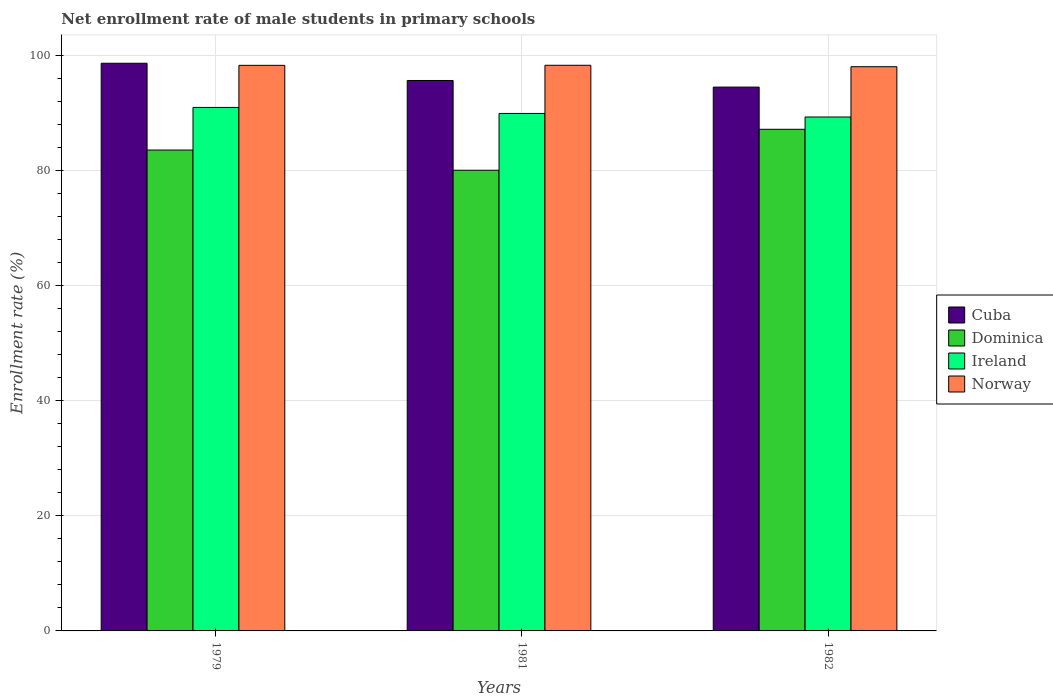How many different coloured bars are there?
Give a very brief answer. 4. Are the number of bars per tick equal to the number of legend labels?
Provide a succinct answer. Yes. Are the number of bars on each tick of the X-axis equal?
Provide a succinct answer. Yes. What is the label of the 1st group of bars from the left?
Keep it short and to the point. 1979. In how many cases, is the number of bars for a given year not equal to the number of legend labels?
Offer a terse response. 0. What is the net enrollment rate of male students in primary schools in Norway in 1981?
Your answer should be compact. 98.27. Across all years, what is the maximum net enrollment rate of male students in primary schools in Norway?
Give a very brief answer. 98.27. Across all years, what is the minimum net enrollment rate of male students in primary schools in Ireland?
Keep it short and to the point. 89.28. In which year was the net enrollment rate of male students in primary schools in Cuba maximum?
Your response must be concise. 1979. What is the total net enrollment rate of male students in primary schools in Norway in the graph?
Give a very brief answer. 294.56. What is the difference between the net enrollment rate of male students in primary schools in Ireland in 1979 and that in 1982?
Offer a very short reply. 1.66. What is the difference between the net enrollment rate of male students in primary schools in Dominica in 1981 and the net enrollment rate of male students in primary schools in Norway in 1979?
Ensure brevity in your answer.  -18.23. What is the average net enrollment rate of male students in primary schools in Cuba per year?
Give a very brief answer. 96.24. In the year 1979, what is the difference between the net enrollment rate of male students in primary schools in Norway and net enrollment rate of male students in primary schools in Dominica?
Keep it short and to the point. 14.72. In how many years, is the net enrollment rate of male students in primary schools in Ireland greater than 72 %?
Offer a very short reply. 3. What is the ratio of the net enrollment rate of male students in primary schools in Norway in 1979 to that in 1981?
Offer a terse response. 1. Is the net enrollment rate of male students in primary schools in Ireland in 1981 less than that in 1982?
Give a very brief answer. No. What is the difference between the highest and the second highest net enrollment rate of male students in primary schools in Ireland?
Keep it short and to the point. 1.05. What is the difference between the highest and the lowest net enrollment rate of male students in primary schools in Norway?
Your answer should be very brief. 0.25. Is it the case that in every year, the sum of the net enrollment rate of male students in primary schools in Ireland and net enrollment rate of male students in primary schools in Dominica is greater than the sum of net enrollment rate of male students in primary schools in Cuba and net enrollment rate of male students in primary schools in Norway?
Offer a very short reply. No. What does the 3rd bar from the left in 1979 represents?
Give a very brief answer. Ireland. What does the 4th bar from the right in 1979 represents?
Make the answer very short. Cuba. Is it the case that in every year, the sum of the net enrollment rate of male students in primary schools in Dominica and net enrollment rate of male students in primary schools in Cuba is greater than the net enrollment rate of male students in primary schools in Norway?
Make the answer very short. Yes. Does the graph contain any zero values?
Give a very brief answer. No. What is the title of the graph?
Your response must be concise. Net enrollment rate of male students in primary schools. What is the label or title of the Y-axis?
Offer a very short reply. Enrollment rate (%). What is the Enrollment rate (%) of Cuba in 1979?
Keep it short and to the point. 98.62. What is the Enrollment rate (%) in Dominica in 1979?
Provide a short and direct response. 83.55. What is the Enrollment rate (%) in Ireland in 1979?
Give a very brief answer. 90.95. What is the Enrollment rate (%) in Norway in 1979?
Provide a succinct answer. 98.26. What is the Enrollment rate (%) in Cuba in 1981?
Keep it short and to the point. 95.63. What is the Enrollment rate (%) in Dominica in 1981?
Your answer should be very brief. 80.03. What is the Enrollment rate (%) of Ireland in 1981?
Offer a terse response. 89.9. What is the Enrollment rate (%) in Norway in 1981?
Keep it short and to the point. 98.27. What is the Enrollment rate (%) of Cuba in 1982?
Your response must be concise. 94.48. What is the Enrollment rate (%) of Dominica in 1982?
Offer a terse response. 87.15. What is the Enrollment rate (%) of Ireland in 1982?
Provide a succinct answer. 89.28. What is the Enrollment rate (%) in Norway in 1982?
Keep it short and to the point. 98.02. Across all years, what is the maximum Enrollment rate (%) in Cuba?
Your answer should be compact. 98.62. Across all years, what is the maximum Enrollment rate (%) of Dominica?
Make the answer very short. 87.15. Across all years, what is the maximum Enrollment rate (%) of Ireland?
Offer a terse response. 90.95. Across all years, what is the maximum Enrollment rate (%) in Norway?
Provide a succinct answer. 98.27. Across all years, what is the minimum Enrollment rate (%) of Cuba?
Offer a very short reply. 94.48. Across all years, what is the minimum Enrollment rate (%) in Dominica?
Provide a short and direct response. 80.03. Across all years, what is the minimum Enrollment rate (%) of Ireland?
Your answer should be very brief. 89.28. Across all years, what is the minimum Enrollment rate (%) of Norway?
Keep it short and to the point. 98.02. What is the total Enrollment rate (%) in Cuba in the graph?
Provide a short and direct response. 288.73. What is the total Enrollment rate (%) of Dominica in the graph?
Keep it short and to the point. 250.73. What is the total Enrollment rate (%) of Ireland in the graph?
Make the answer very short. 270.13. What is the total Enrollment rate (%) in Norway in the graph?
Your answer should be compact. 294.56. What is the difference between the Enrollment rate (%) in Cuba in 1979 and that in 1981?
Your answer should be very brief. 2.99. What is the difference between the Enrollment rate (%) of Dominica in 1979 and that in 1981?
Keep it short and to the point. 3.51. What is the difference between the Enrollment rate (%) in Ireland in 1979 and that in 1981?
Make the answer very short. 1.05. What is the difference between the Enrollment rate (%) of Norway in 1979 and that in 1981?
Provide a short and direct response. -0.01. What is the difference between the Enrollment rate (%) in Cuba in 1979 and that in 1982?
Give a very brief answer. 4.14. What is the difference between the Enrollment rate (%) in Dominica in 1979 and that in 1982?
Offer a very short reply. -3.6. What is the difference between the Enrollment rate (%) in Ireland in 1979 and that in 1982?
Offer a very short reply. 1.66. What is the difference between the Enrollment rate (%) in Norway in 1979 and that in 1982?
Give a very brief answer. 0.24. What is the difference between the Enrollment rate (%) of Cuba in 1981 and that in 1982?
Your response must be concise. 1.15. What is the difference between the Enrollment rate (%) in Dominica in 1981 and that in 1982?
Offer a very short reply. -7.12. What is the difference between the Enrollment rate (%) of Ireland in 1981 and that in 1982?
Your response must be concise. 0.62. What is the difference between the Enrollment rate (%) of Norway in 1981 and that in 1982?
Your answer should be compact. 0.25. What is the difference between the Enrollment rate (%) of Cuba in 1979 and the Enrollment rate (%) of Dominica in 1981?
Provide a succinct answer. 18.59. What is the difference between the Enrollment rate (%) in Cuba in 1979 and the Enrollment rate (%) in Ireland in 1981?
Keep it short and to the point. 8.72. What is the difference between the Enrollment rate (%) in Cuba in 1979 and the Enrollment rate (%) in Norway in 1981?
Provide a succinct answer. 0.35. What is the difference between the Enrollment rate (%) in Dominica in 1979 and the Enrollment rate (%) in Ireland in 1981?
Offer a terse response. -6.36. What is the difference between the Enrollment rate (%) in Dominica in 1979 and the Enrollment rate (%) in Norway in 1981?
Your response must be concise. -14.73. What is the difference between the Enrollment rate (%) in Ireland in 1979 and the Enrollment rate (%) in Norway in 1981?
Your response must be concise. -7.32. What is the difference between the Enrollment rate (%) in Cuba in 1979 and the Enrollment rate (%) in Dominica in 1982?
Provide a short and direct response. 11.47. What is the difference between the Enrollment rate (%) of Cuba in 1979 and the Enrollment rate (%) of Ireland in 1982?
Ensure brevity in your answer.  9.34. What is the difference between the Enrollment rate (%) in Cuba in 1979 and the Enrollment rate (%) in Norway in 1982?
Your answer should be compact. 0.6. What is the difference between the Enrollment rate (%) of Dominica in 1979 and the Enrollment rate (%) of Ireland in 1982?
Give a very brief answer. -5.74. What is the difference between the Enrollment rate (%) in Dominica in 1979 and the Enrollment rate (%) in Norway in 1982?
Your answer should be very brief. -14.48. What is the difference between the Enrollment rate (%) of Ireland in 1979 and the Enrollment rate (%) of Norway in 1982?
Provide a succinct answer. -7.07. What is the difference between the Enrollment rate (%) of Cuba in 1981 and the Enrollment rate (%) of Dominica in 1982?
Provide a succinct answer. 8.48. What is the difference between the Enrollment rate (%) in Cuba in 1981 and the Enrollment rate (%) in Ireland in 1982?
Offer a very short reply. 6.34. What is the difference between the Enrollment rate (%) in Cuba in 1981 and the Enrollment rate (%) in Norway in 1982?
Your answer should be compact. -2.39. What is the difference between the Enrollment rate (%) in Dominica in 1981 and the Enrollment rate (%) in Ireland in 1982?
Your response must be concise. -9.25. What is the difference between the Enrollment rate (%) in Dominica in 1981 and the Enrollment rate (%) in Norway in 1982?
Ensure brevity in your answer.  -17.99. What is the difference between the Enrollment rate (%) in Ireland in 1981 and the Enrollment rate (%) in Norway in 1982?
Keep it short and to the point. -8.12. What is the average Enrollment rate (%) of Cuba per year?
Ensure brevity in your answer.  96.24. What is the average Enrollment rate (%) of Dominica per year?
Offer a terse response. 83.58. What is the average Enrollment rate (%) in Ireland per year?
Your response must be concise. 90.04. What is the average Enrollment rate (%) of Norway per year?
Give a very brief answer. 98.19. In the year 1979, what is the difference between the Enrollment rate (%) in Cuba and Enrollment rate (%) in Dominica?
Your response must be concise. 15.08. In the year 1979, what is the difference between the Enrollment rate (%) in Cuba and Enrollment rate (%) in Ireland?
Your response must be concise. 7.67. In the year 1979, what is the difference between the Enrollment rate (%) in Cuba and Enrollment rate (%) in Norway?
Your answer should be very brief. 0.36. In the year 1979, what is the difference between the Enrollment rate (%) in Dominica and Enrollment rate (%) in Ireland?
Provide a short and direct response. -7.4. In the year 1979, what is the difference between the Enrollment rate (%) of Dominica and Enrollment rate (%) of Norway?
Your response must be concise. -14.72. In the year 1979, what is the difference between the Enrollment rate (%) in Ireland and Enrollment rate (%) in Norway?
Offer a terse response. -7.31. In the year 1981, what is the difference between the Enrollment rate (%) of Cuba and Enrollment rate (%) of Dominica?
Give a very brief answer. 15.59. In the year 1981, what is the difference between the Enrollment rate (%) in Cuba and Enrollment rate (%) in Ireland?
Ensure brevity in your answer.  5.73. In the year 1981, what is the difference between the Enrollment rate (%) of Cuba and Enrollment rate (%) of Norway?
Provide a short and direct response. -2.64. In the year 1981, what is the difference between the Enrollment rate (%) of Dominica and Enrollment rate (%) of Ireland?
Your answer should be compact. -9.87. In the year 1981, what is the difference between the Enrollment rate (%) in Dominica and Enrollment rate (%) in Norway?
Provide a succinct answer. -18.24. In the year 1981, what is the difference between the Enrollment rate (%) of Ireland and Enrollment rate (%) of Norway?
Offer a very short reply. -8.37. In the year 1982, what is the difference between the Enrollment rate (%) of Cuba and Enrollment rate (%) of Dominica?
Provide a short and direct response. 7.33. In the year 1982, what is the difference between the Enrollment rate (%) of Cuba and Enrollment rate (%) of Ireland?
Provide a succinct answer. 5.19. In the year 1982, what is the difference between the Enrollment rate (%) of Cuba and Enrollment rate (%) of Norway?
Keep it short and to the point. -3.54. In the year 1982, what is the difference between the Enrollment rate (%) in Dominica and Enrollment rate (%) in Ireland?
Make the answer very short. -2.13. In the year 1982, what is the difference between the Enrollment rate (%) in Dominica and Enrollment rate (%) in Norway?
Provide a succinct answer. -10.87. In the year 1982, what is the difference between the Enrollment rate (%) in Ireland and Enrollment rate (%) in Norway?
Your response must be concise. -8.74. What is the ratio of the Enrollment rate (%) in Cuba in 1979 to that in 1981?
Make the answer very short. 1.03. What is the ratio of the Enrollment rate (%) of Dominica in 1979 to that in 1981?
Make the answer very short. 1.04. What is the ratio of the Enrollment rate (%) of Ireland in 1979 to that in 1981?
Your answer should be compact. 1.01. What is the ratio of the Enrollment rate (%) of Norway in 1979 to that in 1981?
Provide a short and direct response. 1. What is the ratio of the Enrollment rate (%) of Cuba in 1979 to that in 1982?
Provide a short and direct response. 1.04. What is the ratio of the Enrollment rate (%) in Dominica in 1979 to that in 1982?
Keep it short and to the point. 0.96. What is the ratio of the Enrollment rate (%) in Ireland in 1979 to that in 1982?
Your answer should be very brief. 1.02. What is the ratio of the Enrollment rate (%) of Norway in 1979 to that in 1982?
Offer a terse response. 1. What is the ratio of the Enrollment rate (%) in Cuba in 1981 to that in 1982?
Offer a terse response. 1.01. What is the ratio of the Enrollment rate (%) in Dominica in 1981 to that in 1982?
Keep it short and to the point. 0.92. What is the ratio of the Enrollment rate (%) of Ireland in 1981 to that in 1982?
Offer a very short reply. 1.01. What is the difference between the highest and the second highest Enrollment rate (%) of Cuba?
Offer a terse response. 2.99. What is the difference between the highest and the second highest Enrollment rate (%) of Dominica?
Offer a terse response. 3.6. What is the difference between the highest and the second highest Enrollment rate (%) in Ireland?
Give a very brief answer. 1.05. What is the difference between the highest and the second highest Enrollment rate (%) of Norway?
Provide a succinct answer. 0.01. What is the difference between the highest and the lowest Enrollment rate (%) of Cuba?
Offer a very short reply. 4.14. What is the difference between the highest and the lowest Enrollment rate (%) in Dominica?
Offer a terse response. 7.12. What is the difference between the highest and the lowest Enrollment rate (%) in Ireland?
Provide a short and direct response. 1.66. What is the difference between the highest and the lowest Enrollment rate (%) in Norway?
Make the answer very short. 0.25. 